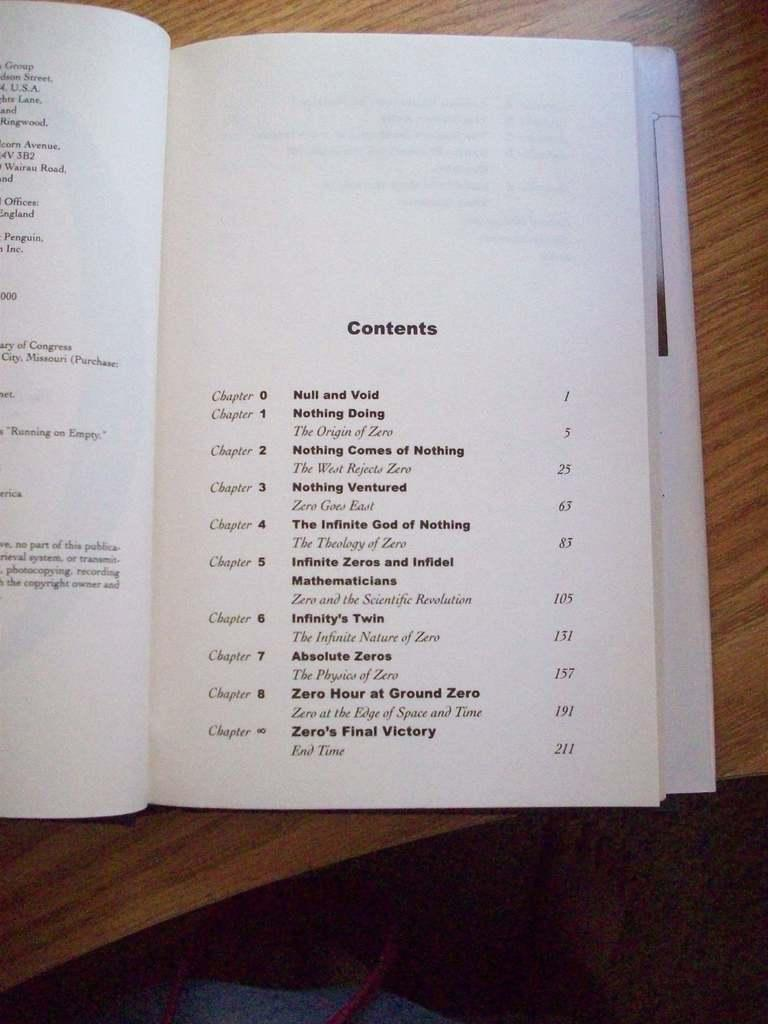<image>
Summarize the visual content of the image. A book laying on a table opened up to the Contents page. 